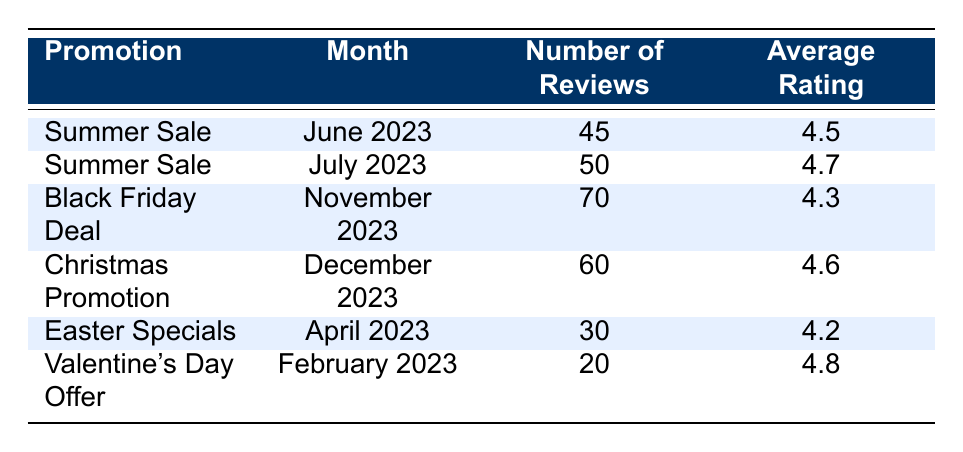What is the average rating for the "Summer Sale" promotion? The table shows two entries for the "Summer Sale" promotion, one in June with an average rating of 4.5 and another in July with an average rating of 4.7. To find the average, we can sum the ratings (4.5 + 4.7 = 9.2) and divide by the number of entries (2). Therefore, the average rating is 9.2 / 2 = 4.6.
Answer: 4.6 How many total reviews were generated during the "Christmas Promotion"? The table indicates that there are 60 reviews associated with the "Christmas Promotion." Thus, the total number of reviews for this promotion is simply stated in the table.
Answer: 60 Did the “Valentine's Day Offer” receive a higher average rating than the “Easter Specials”? The average rating for "Valentine's Day Offer" is 4.8, while the average rating for "Easter Specials" is 4.2. Since 4.8 is greater than 4.2, the answer is yes.
Answer: Yes What promotional event had the highest number of reviews? By examining the table, the "Black Friday Deal" has the highest number of reviews at 70. Therefore, this is the event with the most reviews among all listed.
Answer: Black Friday Deal What is the total number of reviews recorded for all promotions listed in the table? Adding the number of reviews from all promotions: 45 (Summer Sale June) + 50 (Summer Sale July) + 70 (Black Friday Deal) + 60 (Christmas Promotion) + 30 (Easter Specials) + 20 (Valentine's Day Offer) = 275. Thus, the total number of reviews across all promotions is 275.
Answer: 275 Is the average rating of the "Black Friday Deal" below 4.5? The average rating for the "Black Friday Deal" is 4.3. Since 4.3 is less than 4.5, the answer to the question is yes.
Answer: Yes Which promotional month had the least number of reviews? Looking through the table, "Valentine's Day Offer" in February has the least number of reviews, totaling 20. This makes it the month with the fewest reviews in the dataset.
Answer: February What is the difference in average ratings between the "Christmas Promotion" and the "Black Friday Deal"? The average rating for the "Christmas Promotion" is 4.6, while for the "Black Friday Deal," it is 4.3. To find the difference, calculate 4.6 - 4.3 = 0.3. So, the difference in average ratings is 0.3.
Answer: 0.3 